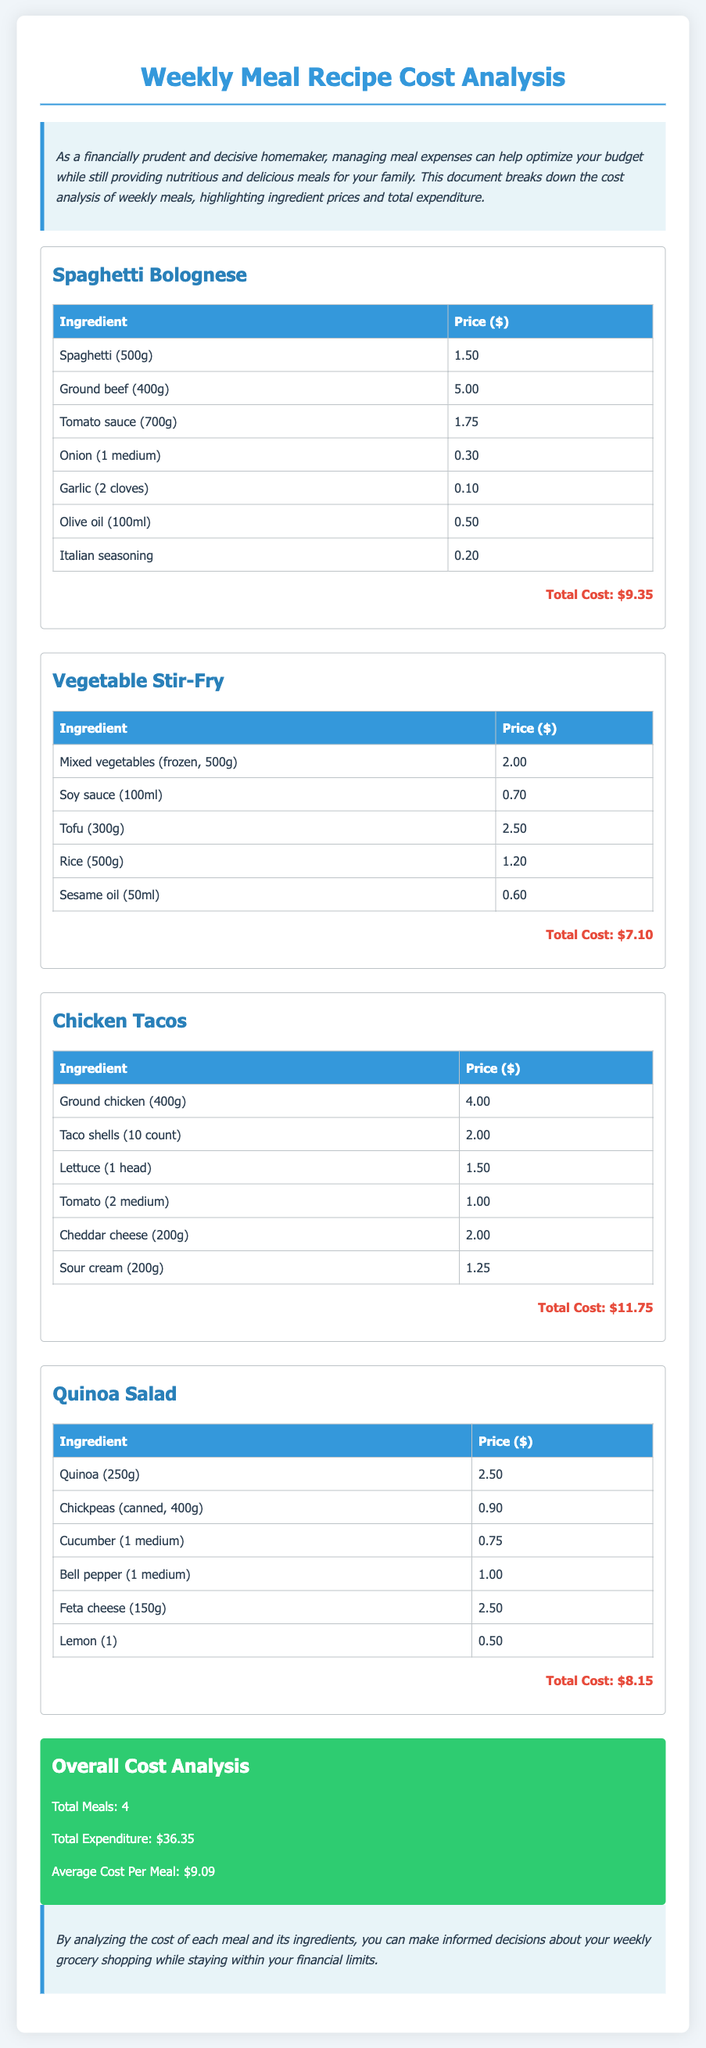what is the total cost of Spaghetti Bolognese? The total cost is explicitly listed under the meal section, which states the cost as $9.35.
Answer: $9.35 how much does ground chicken cost? The price is provided in the Chicken Tacos section, which lists it as $4.00.
Answer: $4.00 what is the average cost per meal? The average cost per meal is calculated from the total expenditure divided by the number of meals, stated as $9.09.
Answer: $9.09 which meal has the highest total cost? By comparing the total costs listed for each meal, Chicken Tacos, with a total cost of $11.75, has the highest cost.
Answer: Chicken Tacos what are the total expenditures for the week? The overall cost analysis section summarizes expenditures, stating the total expenditure is $36.35.
Answer: $36.35 which ingredient in the Quinoa Salad has the highest price? The ingredient prices are listed, showing that Feta cheese at $2.50 is the highest in this meal.
Answer: Feta cheese how many total meals are analyzed in the document? The overall cost analysis section clearly states that there are 4 meals included in the analysis.
Answer: 4 what is the total price of mixed vegetables for Vegetable Stir-Fry? The price is provided in the Vegetable Stir-Fry section, listed as $2.00.
Answer: $2.00 how much does olive oil cost for Spaghetti Bolognese? The cost for olive oil is listed in the Spaghetti Bolognese section, which is $0.50.
Answer: $0.50 